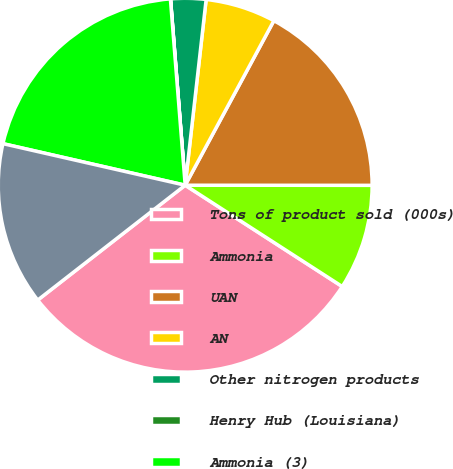Convert chart. <chart><loc_0><loc_0><loc_500><loc_500><pie_chart><fcel>Tons of product sold (000s)<fcel>Ammonia<fcel>UAN<fcel>AN<fcel>Other nitrogen products<fcel>Henry Hub (Louisiana)<fcel>Ammonia (3)<fcel>UAN (32)<nl><fcel>30.35%<fcel>9.11%<fcel>17.14%<fcel>6.08%<fcel>3.04%<fcel>0.01%<fcel>20.17%<fcel>14.1%<nl></chart> 